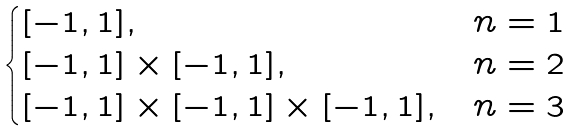<formula> <loc_0><loc_0><loc_500><loc_500>\begin{cases} [ - 1 , 1 ] , & \text {$n=1$} \\ [ - 1 , 1 ] \times [ - 1 , 1 ] , & \text {$n=2$} \\ [ - 1 , 1 ] \times [ - 1 , 1 ] \times [ - 1 , 1 ] , & \text {$n=3$} \end{cases}</formula> 